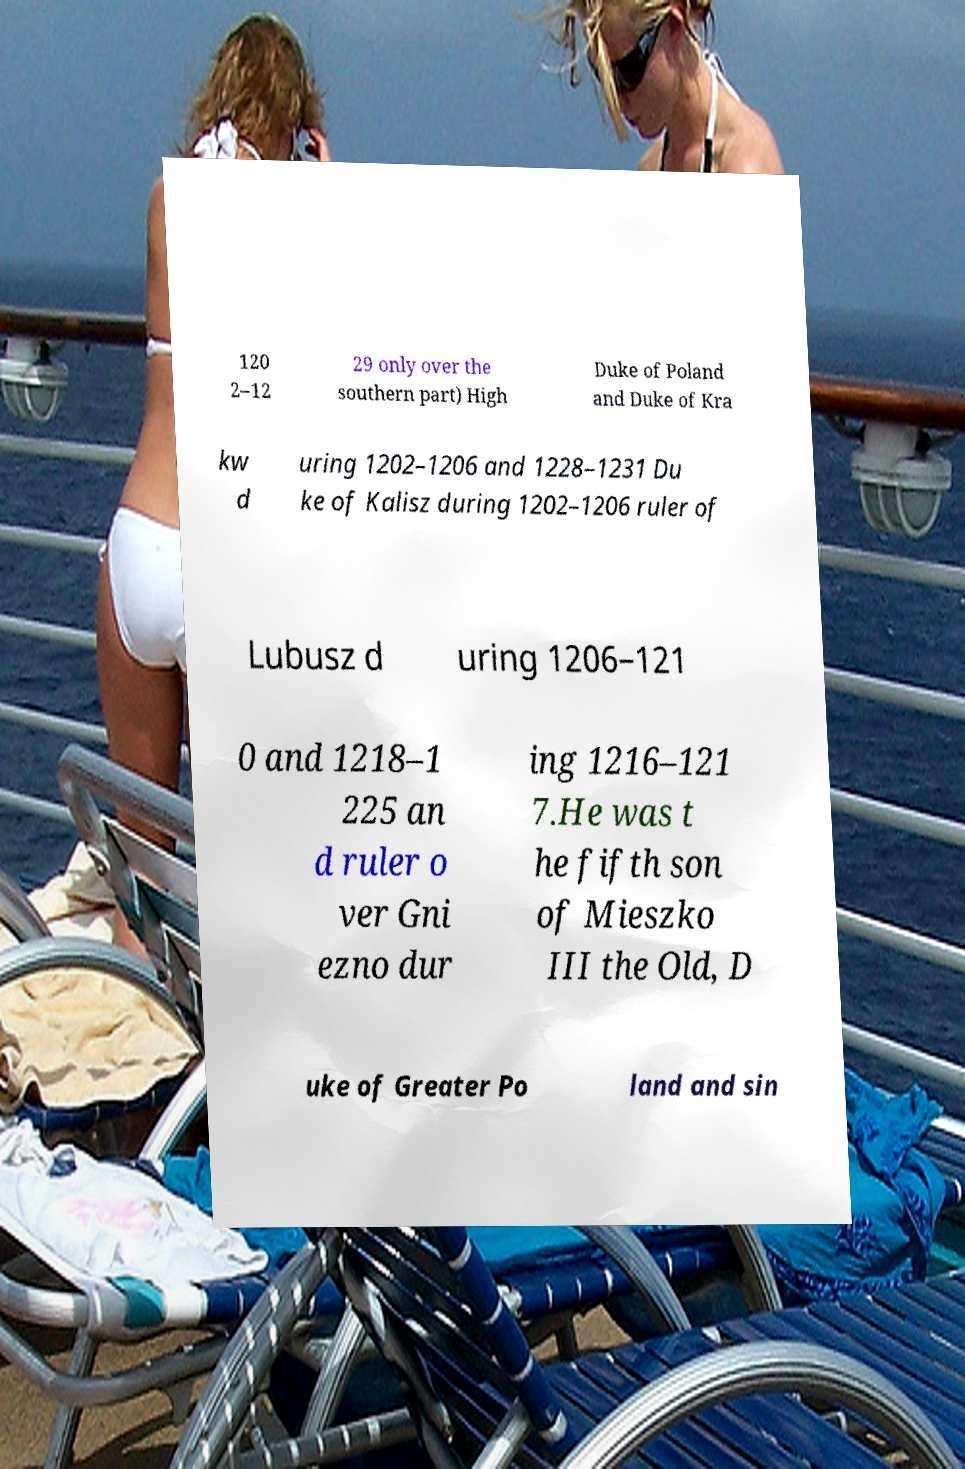Please read and relay the text visible in this image. What does it say? 120 2–12 29 only over the southern part) High Duke of Poland and Duke of Kra kw d uring 1202–1206 and 1228–1231 Du ke of Kalisz during 1202–1206 ruler of Lubusz d uring 1206–121 0 and 1218–1 225 an d ruler o ver Gni ezno dur ing 1216–121 7.He was t he fifth son of Mieszko III the Old, D uke of Greater Po land and sin 